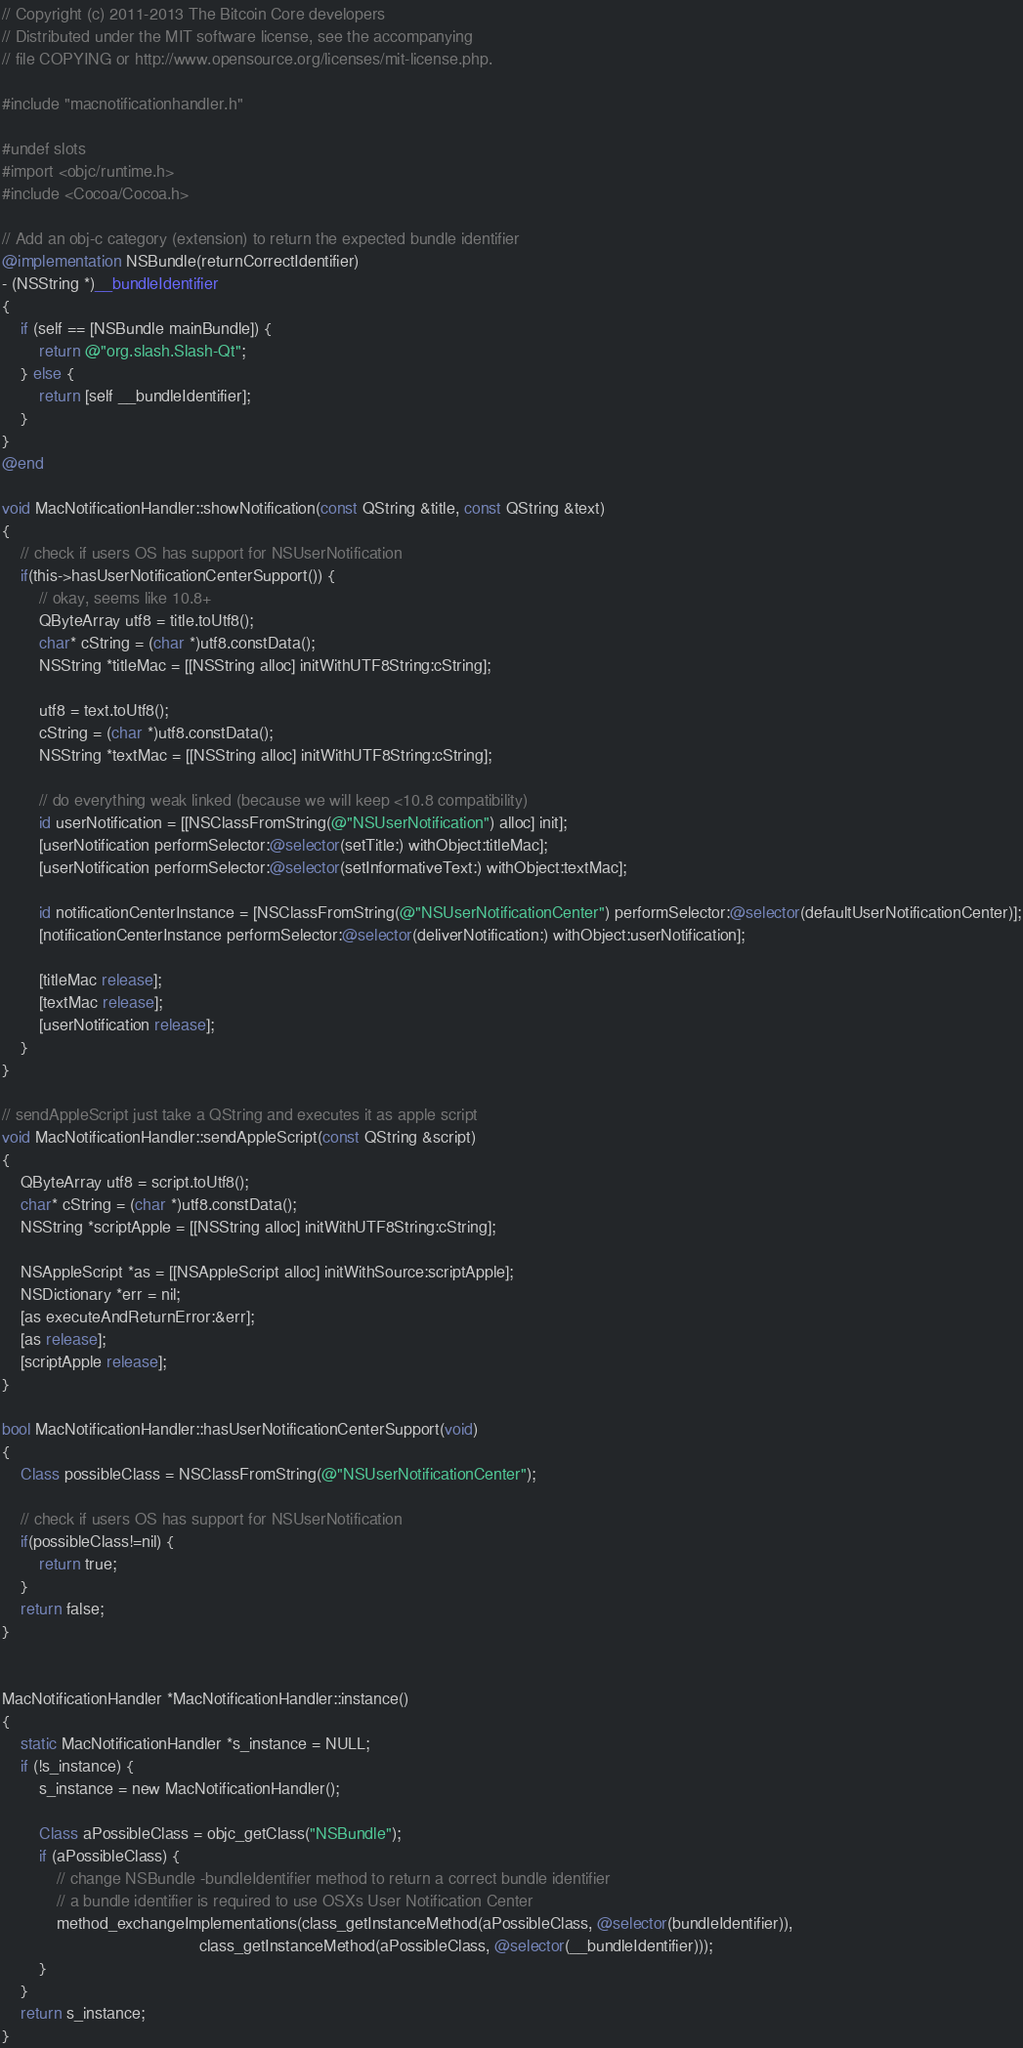<code> <loc_0><loc_0><loc_500><loc_500><_ObjectiveC_>// Copyright (c) 2011-2013 The Bitcoin Core developers
// Distributed under the MIT software license, see the accompanying
// file COPYING or http://www.opensource.org/licenses/mit-license.php.

#include "macnotificationhandler.h"

#undef slots
#import <objc/runtime.h>
#include <Cocoa/Cocoa.h>

// Add an obj-c category (extension) to return the expected bundle identifier
@implementation NSBundle(returnCorrectIdentifier)
- (NSString *)__bundleIdentifier
{
    if (self == [NSBundle mainBundle]) {
        return @"org.slash.Slash-Qt";
    } else {
        return [self __bundleIdentifier];
    }
}
@end

void MacNotificationHandler::showNotification(const QString &title, const QString &text)
{
    // check if users OS has support for NSUserNotification
    if(this->hasUserNotificationCenterSupport()) {
        // okay, seems like 10.8+
        QByteArray utf8 = title.toUtf8();
        char* cString = (char *)utf8.constData();
        NSString *titleMac = [[NSString alloc] initWithUTF8String:cString];

        utf8 = text.toUtf8();
        cString = (char *)utf8.constData();
        NSString *textMac = [[NSString alloc] initWithUTF8String:cString];

        // do everything weak linked (because we will keep <10.8 compatibility)
        id userNotification = [[NSClassFromString(@"NSUserNotification") alloc] init];
        [userNotification performSelector:@selector(setTitle:) withObject:titleMac];
        [userNotification performSelector:@selector(setInformativeText:) withObject:textMac];

        id notificationCenterInstance = [NSClassFromString(@"NSUserNotificationCenter") performSelector:@selector(defaultUserNotificationCenter)];
        [notificationCenterInstance performSelector:@selector(deliverNotification:) withObject:userNotification];

        [titleMac release];
        [textMac release];
        [userNotification release];
    }
}

// sendAppleScript just take a QString and executes it as apple script
void MacNotificationHandler::sendAppleScript(const QString &script)
{
    QByteArray utf8 = script.toUtf8();
    char* cString = (char *)utf8.constData();
    NSString *scriptApple = [[NSString alloc] initWithUTF8String:cString];

    NSAppleScript *as = [[NSAppleScript alloc] initWithSource:scriptApple];
    NSDictionary *err = nil;
    [as executeAndReturnError:&err];
    [as release];
    [scriptApple release];
}

bool MacNotificationHandler::hasUserNotificationCenterSupport(void)
{
    Class possibleClass = NSClassFromString(@"NSUserNotificationCenter");

    // check if users OS has support for NSUserNotification
    if(possibleClass!=nil) {
        return true;
    }
    return false;
}


MacNotificationHandler *MacNotificationHandler::instance()
{
    static MacNotificationHandler *s_instance = NULL;
    if (!s_instance) {
        s_instance = new MacNotificationHandler();
        
        Class aPossibleClass = objc_getClass("NSBundle");
        if (aPossibleClass) {
            // change NSBundle -bundleIdentifier method to return a correct bundle identifier
            // a bundle identifier is required to use OSXs User Notification Center
            method_exchangeImplementations(class_getInstanceMethod(aPossibleClass, @selector(bundleIdentifier)),
                                           class_getInstanceMethod(aPossibleClass, @selector(__bundleIdentifier)));
        }
    }
    return s_instance;
}
</code> 